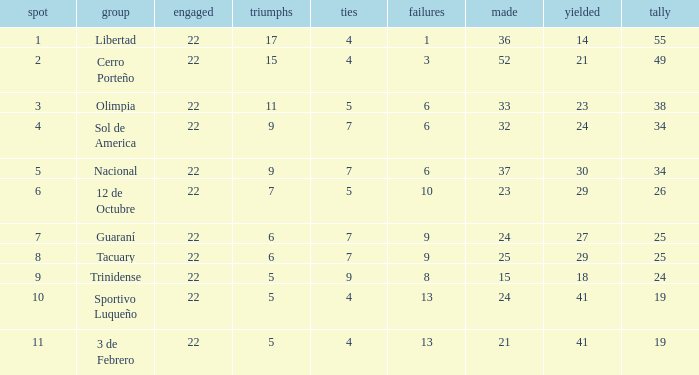What is the value scored when there were 19 points for the team 3 de Febrero? 21.0. 